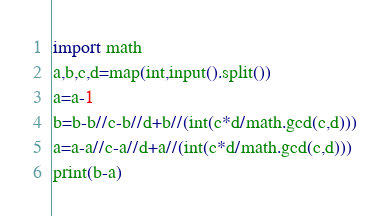Convert code to text. <code><loc_0><loc_0><loc_500><loc_500><_Python_>import math
a,b,c,d=map(int,input().split())
a=a-1
b=b-b//c-b//d+b//(int(c*d/math.gcd(c,d)))
a=a-a//c-a//d+a//(int(c*d/math.gcd(c,d)))
print(b-a)</code> 